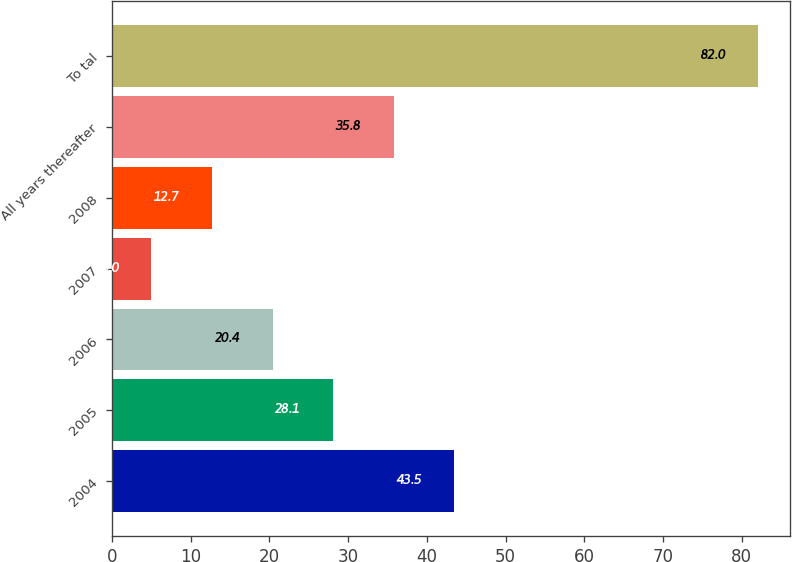<chart> <loc_0><loc_0><loc_500><loc_500><bar_chart><fcel>2004<fcel>2005<fcel>2006<fcel>2007<fcel>2008<fcel>All years thereafter<fcel>To tal<nl><fcel>43.5<fcel>28.1<fcel>20.4<fcel>5<fcel>12.7<fcel>35.8<fcel>82<nl></chart> 